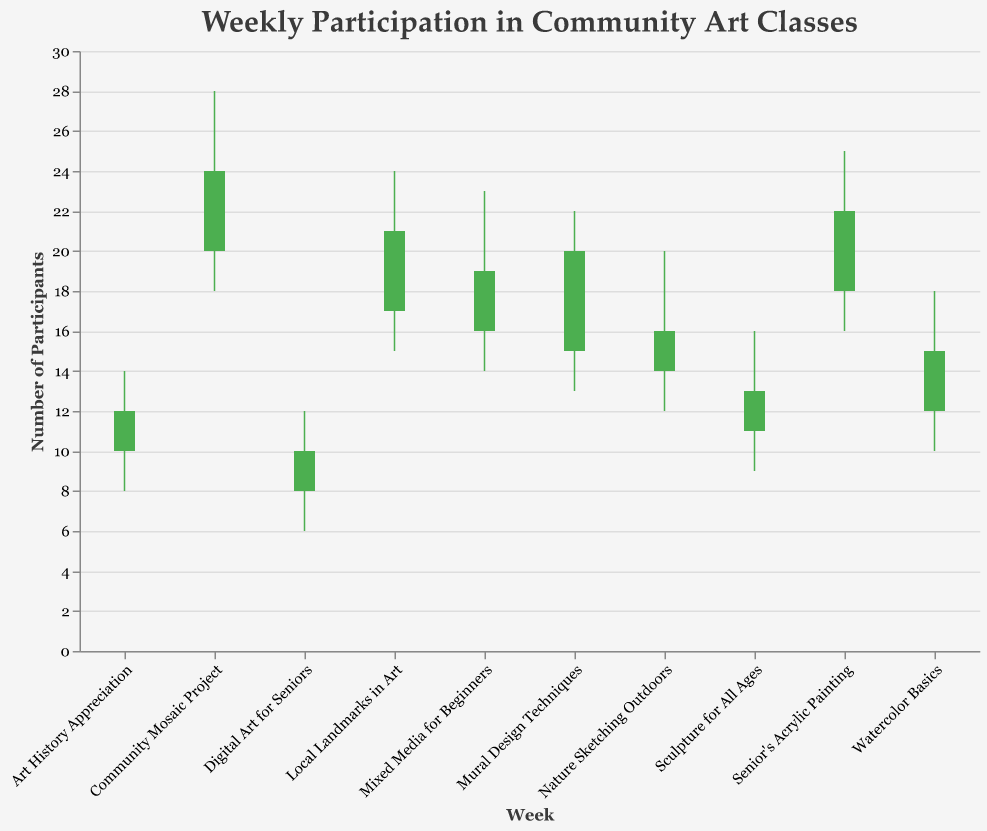How many participants were there at the close of the "Senior's Acrylic Painting" class? The number of participants at the end of the week for the "Senior's Acrylic Painting" class, as shown in the Close column, is 22.
Answer: 22 Which community art class had the highest peak attendance? The class with the highest peak attendance can be determined by looking at the highest number in the High column, which is 28 for the "Community Mosaic Project."
Answer: Community Mosaic Project What is the difference between the highest and lowest attendance in the "Local Landmarks in Art" class? To find the difference, subtract the lowest attendance (Low) from the highest attendance (High) for the "Local Landmarks in Art" class: 24 - 15 = 9.
Answer: 9 On which day did the "Mixed Media for Beginners" class start with 16 participants? By inspecting the Open column, we see that the number of participants at the start of the week for "Mixed Media for Beginners" is 16.
Answer: Mixed Media for Beginners Compare the starting attendance of "Digital Art for Seniors" to "Sculpture for All Ages" and determine which had a higher value. "Digital Art for Seniors" had a starting attendance (Open) of 8, and "Sculpture for All Ages" had 11. Therefore, "Sculpture for All Ages" had a higher starting attendance.
Answer: Sculpture for All Ages Calculate the average closing attendance across all classes. First, sum the Close values for all classes: 15 + 20 + 12 + 22 + 24 + 16 + 19 + 13 + 10 + 21 = 172. Then divide by the number of classes (10): 172 / 10 = 17.2.
Answer: 17.2 Which class saw the largest increase in attendance from the start to the end of the week? To find the largest increase, subtract the Open value from the Close value for each class and identify the highest result. The largest increase is 9 (20 - 15) for "Mural Design Techniques.”
Answer: Mural Design Techniques For "Nature Sketching Outdoors", what is the range of attendance over the week? The range is calculated by subtracting the lowest attendance (Low) from the highest attendance (High): 20 - 12 = 8.
Answer: 8 In which week did the attendance decrease the most from start to end? First, calculate the difference between the Open and Close values for each week. The biggest decrease is 2 (12 - 10) for "Art History Appreciation."
Answer: Art History Appreciation How often is the closing attendance higher than the starting attendance across the offered classes? Count the instances where the Close value is greater than the Open value: "Watercolor Basics," "Mural Design Techniques," "Senior's Acrylic Painting," "Community Mosaic Project," "Mixed Media for Beginners," and "Local Landmarks in Art" (6 times).
Answer: 6 